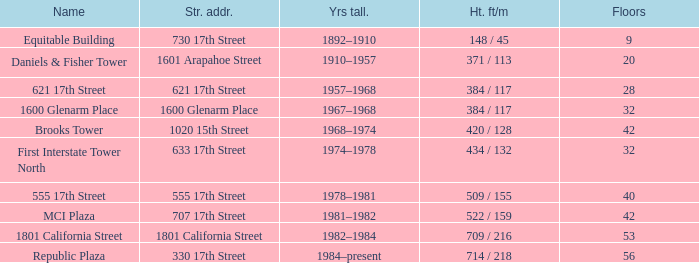What is the altitude of the construction with 40 levels? 509 / 155. 